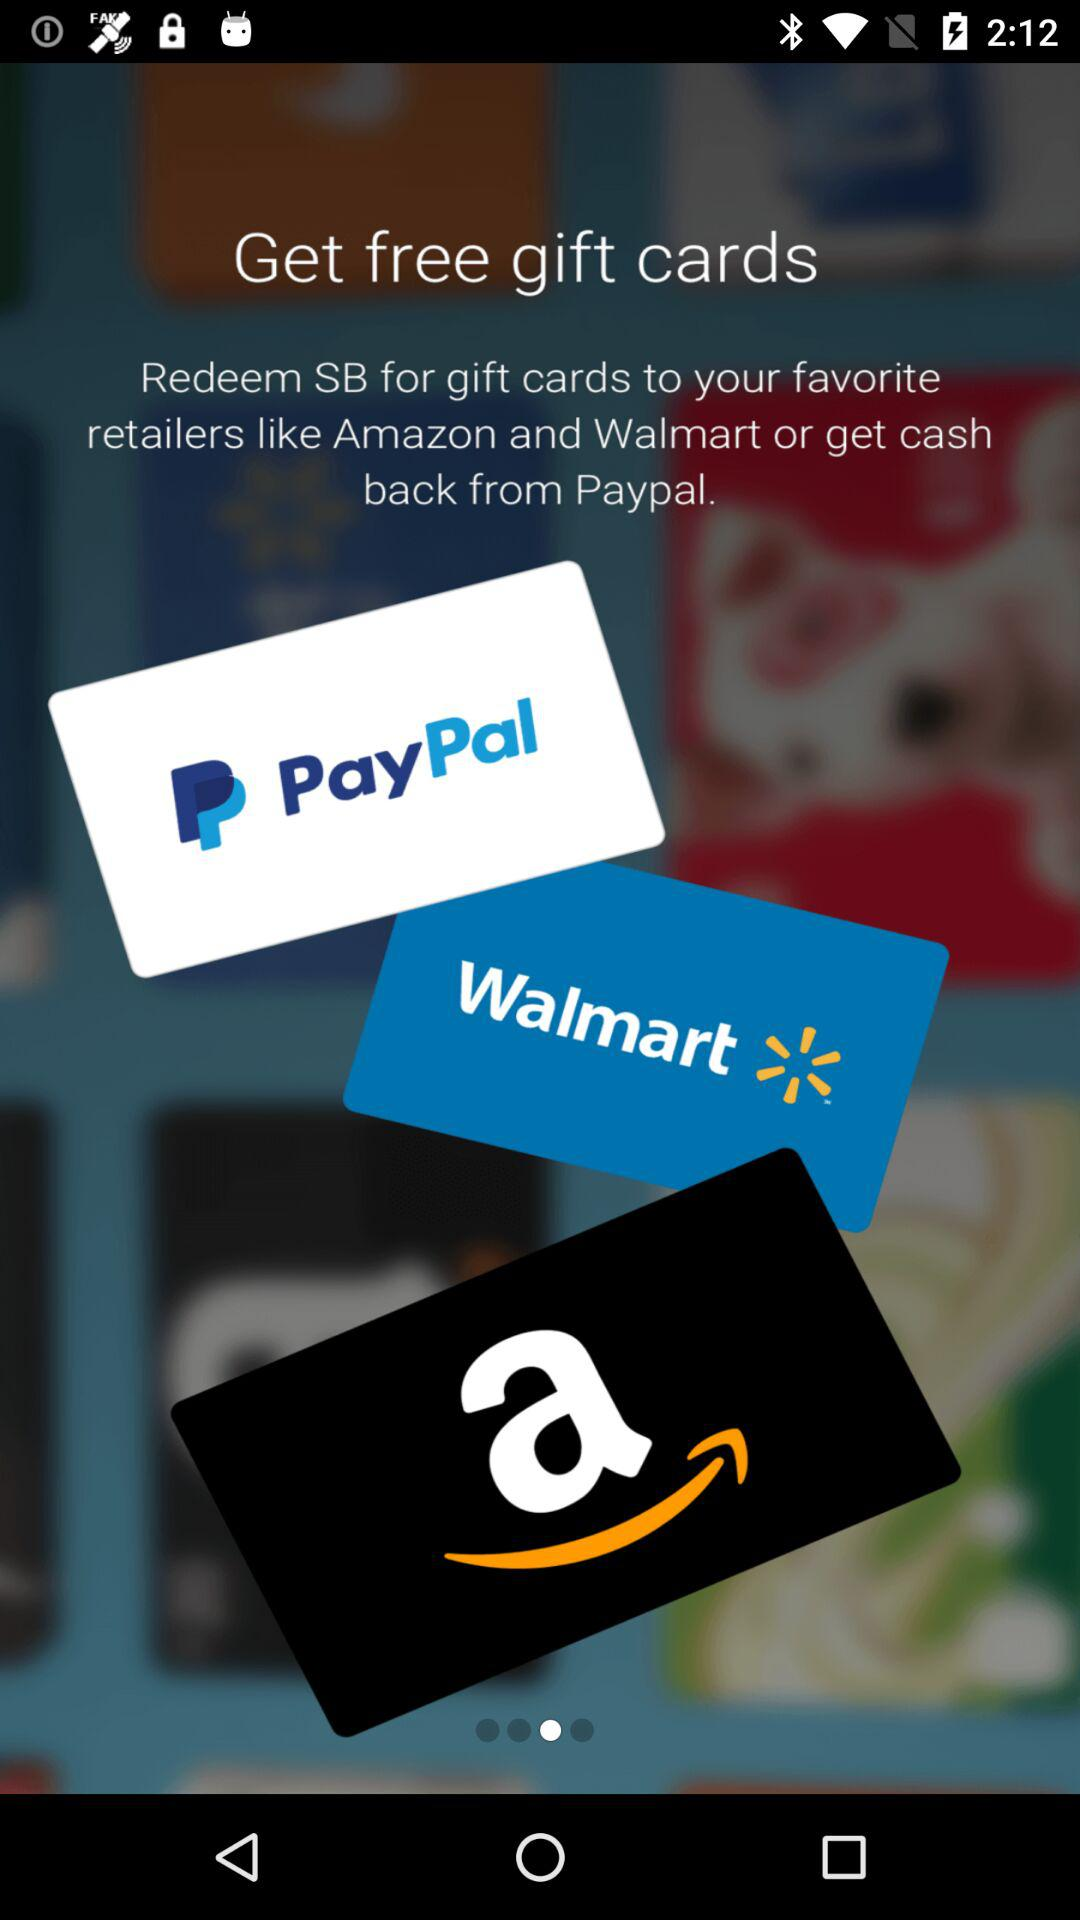How many gift cards are displayed on the screen?
Answer the question using a single word or phrase. 3 